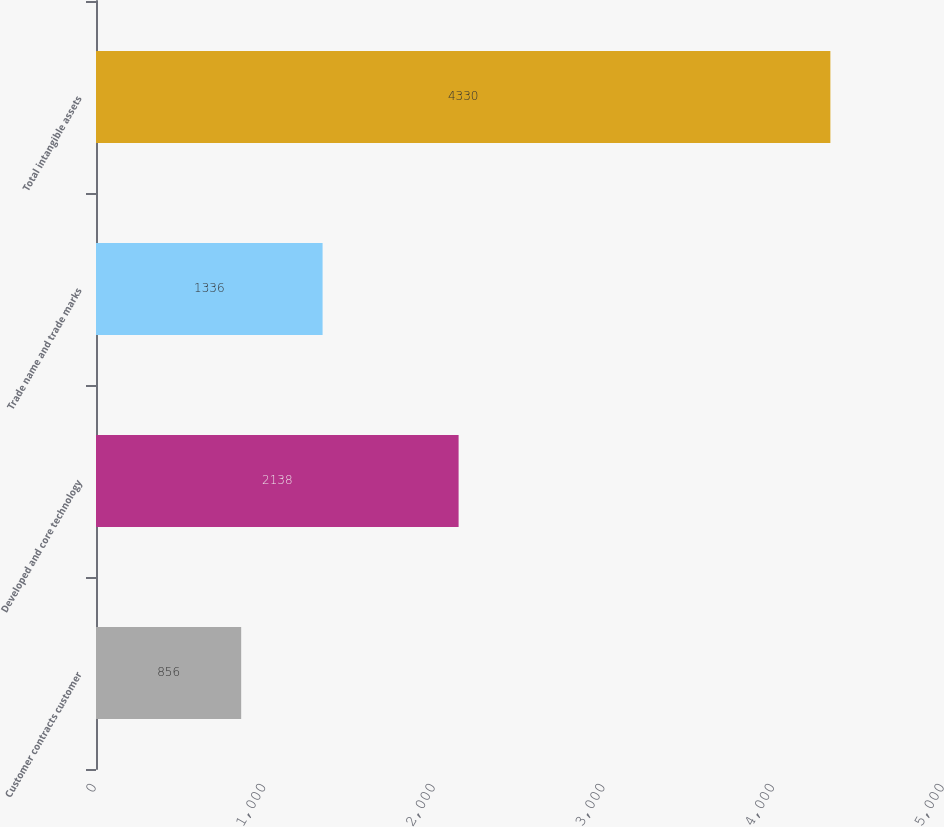Convert chart. <chart><loc_0><loc_0><loc_500><loc_500><bar_chart><fcel>Customer contracts customer<fcel>Developed and core technology<fcel>Trade name and trade marks<fcel>Total intangible assets<nl><fcel>856<fcel>2138<fcel>1336<fcel>4330<nl></chart> 